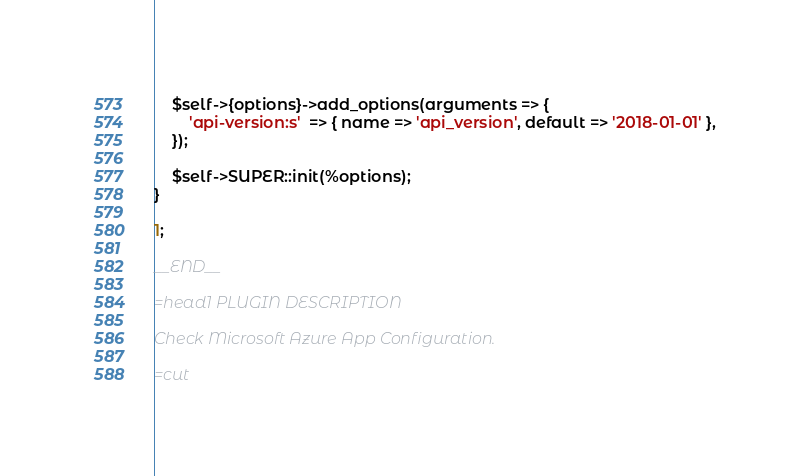<code> <loc_0><loc_0><loc_500><loc_500><_Perl_>    $self->{options}->add_options(arguments => {
        'api-version:s'  => { name => 'api_version', default => '2018-01-01' },
    });

    $self->SUPER::init(%options);
}

1;

__END__

=head1 PLUGIN DESCRIPTION

Check Microsoft Azure App Configuration.

=cut</code> 